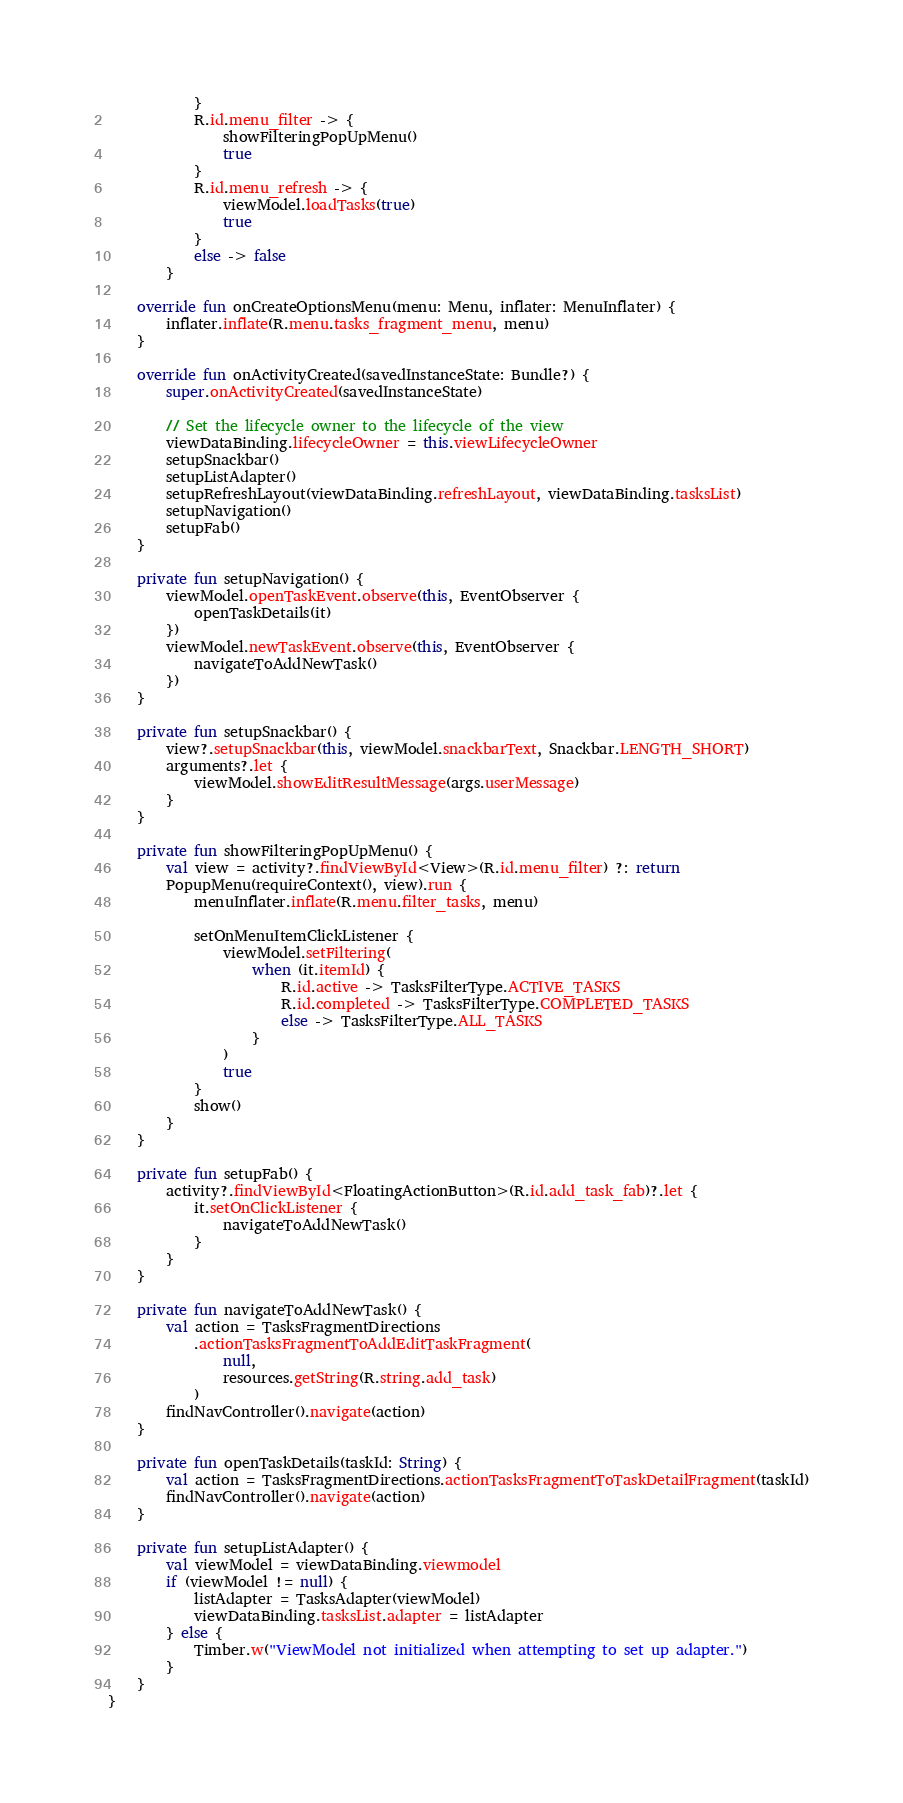<code> <loc_0><loc_0><loc_500><loc_500><_Kotlin_>            }
            R.id.menu_filter -> {
                showFilteringPopUpMenu()
                true
            }
            R.id.menu_refresh -> {
                viewModel.loadTasks(true)
                true
            }
            else -> false
        }

    override fun onCreateOptionsMenu(menu: Menu, inflater: MenuInflater) {
        inflater.inflate(R.menu.tasks_fragment_menu, menu)
    }

    override fun onActivityCreated(savedInstanceState: Bundle?) {
        super.onActivityCreated(savedInstanceState)

        // Set the lifecycle owner to the lifecycle of the view
        viewDataBinding.lifecycleOwner = this.viewLifecycleOwner
        setupSnackbar()
        setupListAdapter()
        setupRefreshLayout(viewDataBinding.refreshLayout, viewDataBinding.tasksList)
        setupNavigation()
        setupFab()
    }

    private fun setupNavigation() {
        viewModel.openTaskEvent.observe(this, EventObserver {
            openTaskDetails(it)
        })
        viewModel.newTaskEvent.observe(this, EventObserver {
            navigateToAddNewTask()
        })
    }

    private fun setupSnackbar() {
        view?.setupSnackbar(this, viewModel.snackbarText, Snackbar.LENGTH_SHORT)
        arguments?.let {
            viewModel.showEditResultMessage(args.userMessage)
        }
    }

    private fun showFilteringPopUpMenu() {
        val view = activity?.findViewById<View>(R.id.menu_filter) ?: return
        PopupMenu(requireContext(), view).run {
            menuInflater.inflate(R.menu.filter_tasks, menu)

            setOnMenuItemClickListener {
                viewModel.setFiltering(
                    when (it.itemId) {
                        R.id.active -> TasksFilterType.ACTIVE_TASKS
                        R.id.completed -> TasksFilterType.COMPLETED_TASKS
                        else -> TasksFilterType.ALL_TASKS
                    }
                )
                true
            }
            show()
        }
    }

    private fun setupFab() {
        activity?.findViewById<FloatingActionButton>(R.id.add_task_fab)?.let {
            it.setOnClickListener {
                navigateToAddNewTask()
            }
        }
    }

    private fun navigateToAddNewTask() {
        val action = TasksFragmentDirections
            .actionTasksFragmentToAddEditTaskFragment(
                null,
                resources.getString(R.string.add_task)
            )
        findNavController().navigate(action)
    }

    private fun openTaskDetails(taskId: String) {
        val action = TasksFragmentDirections.actionTasksFragmentToTaskDetailFragment(taskId)
        findNavController().navigate(action)
    }

    private fun setupListAdapter() {
        val viewModel = viewDataBinding.viewmodel
        if (viewModel != null) {
            listAdapter = TasksAdapter(viewModel)
            viewDataBinding.tasksList.adapter = listAdapter
        } else {
            Timber.w("ViewModel not initialized when attempting to set up adapter.")
        }
    }
}
</code> 